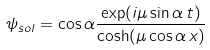Convert formula to latex. <formula><loc_0><loc_0><loc_500><loc_500>\psi _ { s o l } = \cos \alpha \frac { \exp ( i \mu \sin \alpha \, t ) } { \cosh ( \mu \cos \alpha \, x ) }</formula> 